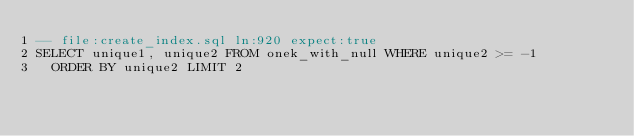<code> <loc_0><loc_0><loc_500><loc_500><_SQL_>-- file:create_index.sql ln:920 expect:true
SELECT unique1, unique2 FROM onek_with_null WHERE unique2 >= -1
  ORDER BY unique2 LIMIT 2
</code> 